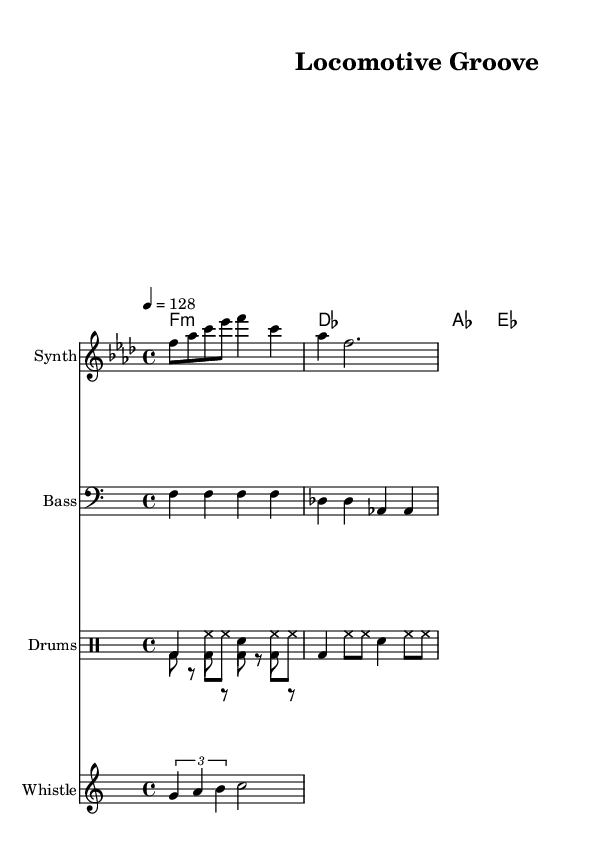What is the key signature of this music? The key signature is F minor, which has four flats (B♭, E♭, A♭, D♭). This can be confirmed by identifying the key signature marking at the beginning of the staff.
Answer: F minor What is the time signature? The time signature is 4/4, indicated by the notation located at the beginning of the sheet music. This means there are four beats in each measure and the quarter note gets one beat.
Answer: 4/4 What is the tempo marking? The tempo marking is 128 BPM, specified as "4 = 128". This indicates the music should be played at a lively pace, with each quarter note counted as 128 beats per minute.
Answer: 128 What instrument plays the melody? The melody is played by the Synth, which is clearly labeled at the top of the corresponding staff on the sheet music.
Answer: Synth Which rhythmic element mimics a train sound? The train whistle is represented in the score and consists of a sequence of notes (g, a, b, c) that imitate the sound of a train whistle. This can be found in the staff designated for the Whistle instrument.
Answer: Train whistle How many bars are in the melody section? The melody section has a total of three bars displayed, which can be counted visually in the Melody staff area from the starting note to the end of the last measure.
Answer: 3 What type of drum pattern is used in this track? The drum pattern consists of bass drum (bd), hi-hat (hh), and snare (sn) elements, typical of house music, used to create an upbeat rhythm. This can be seen in the drum staff where the different drum sounds are notated.
Answer: Drum pattern 